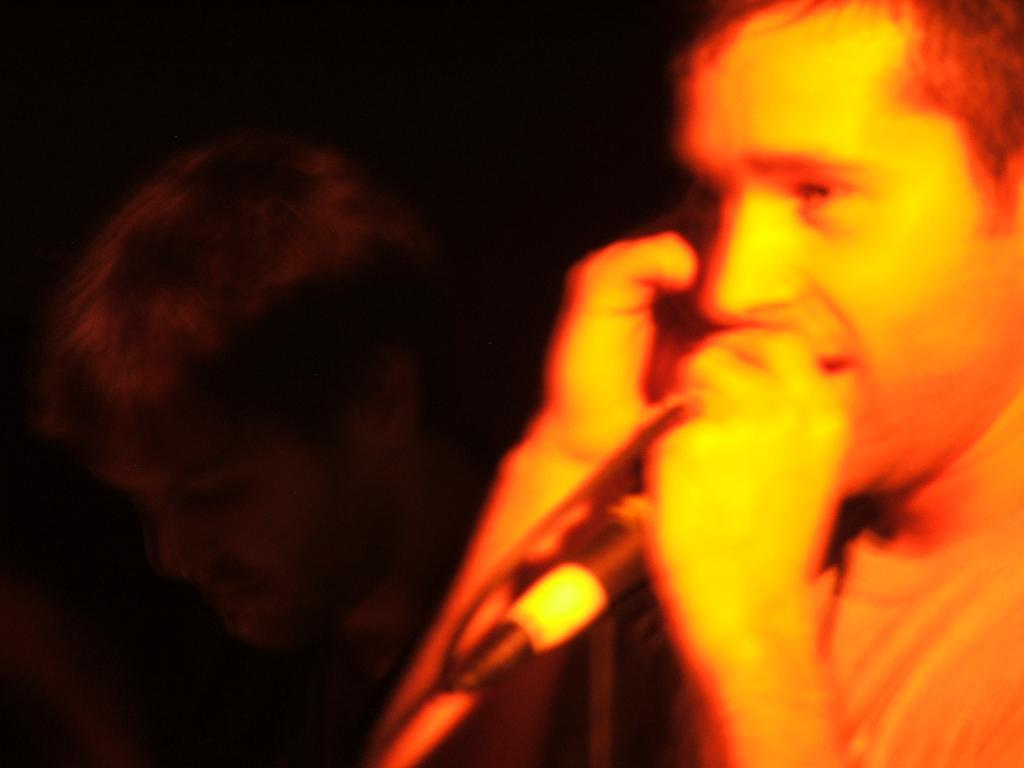How many people are in the image? There are two persons in the image. What is one of the persons holding? One of the persons is holding a microphone. What can be observed about the background of the image? The background of the image is dark. What type of science experiment is being conducted in the image? There is no science experiment present in the image; it features two persons and a microphone. Can you see a bottle in the image? There is no bottle visible in the image. 